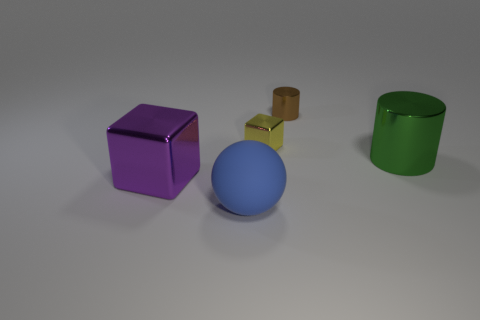Subtract all spheres. How many objects are left? 4 Subtract 1 cylinders. How many cylinders are left? 1 Subtract all yellow blocks. Subtract all red cylinders. How many blocks are left? 1 Subtract all blue blocks. How many purple cylinders are left? 0 Subtract all purple objects. Subtract all tiny metal cylinders. How many objects are left? 3 Add 1 matte balls. How many matte balls are left? 2 Add 2 big cylinders. How many big cylinders exist? 3 Add 2 small brown matte cubes. How many objects exist? 7 Subtract all brown cylinders. How many cylinders are left? 1 Subtract 0 yellow spheres. How many objects are left? 5 